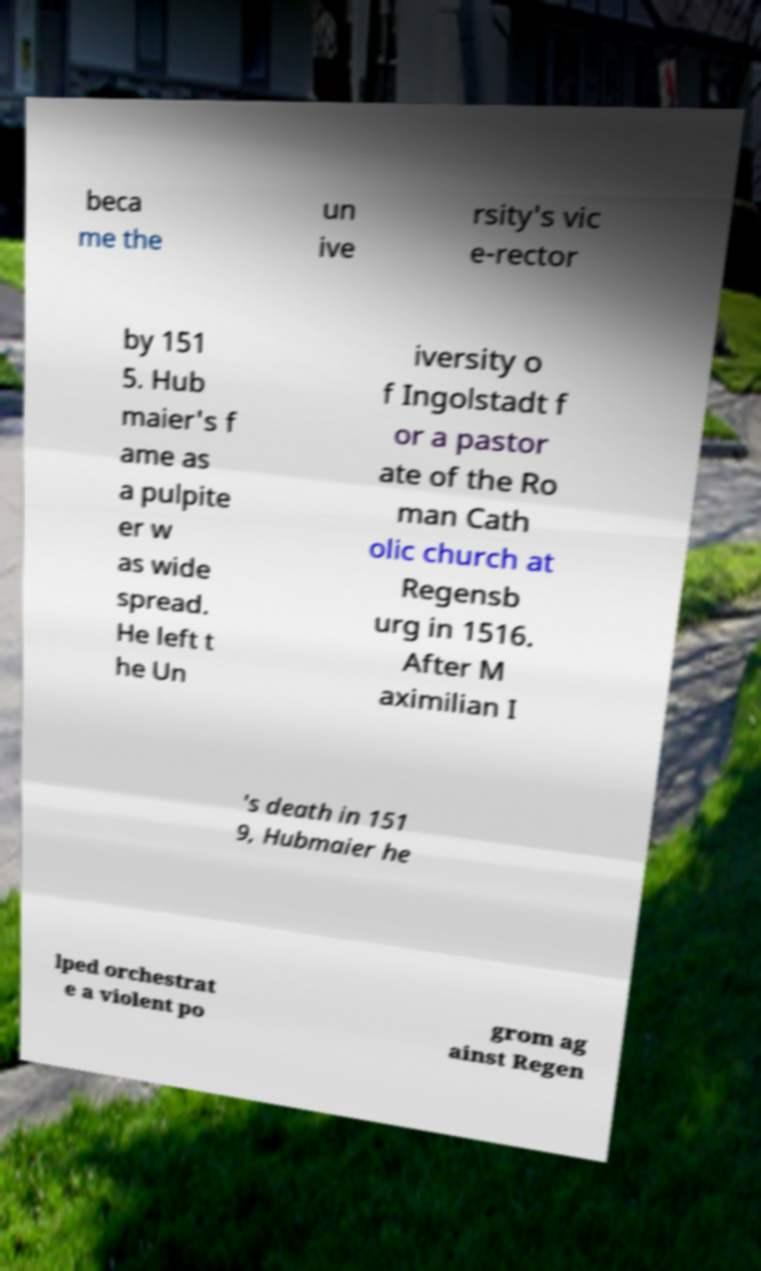Can you accurately transcribe the text from the provided image for me? beca me the un ive rsity's vic e-rector by 151 5. Hub maier's f ame as a pulpite er w as wide spread. He left t he Un iversity o f Ingolstadt f or a pastor ate of the Ro man Cath olic church at Regensb urg in 1516. After M aximilian I 's death in 151 9, Hubmaier he lped orchestrat e a violent po grom ag ainst Regen 